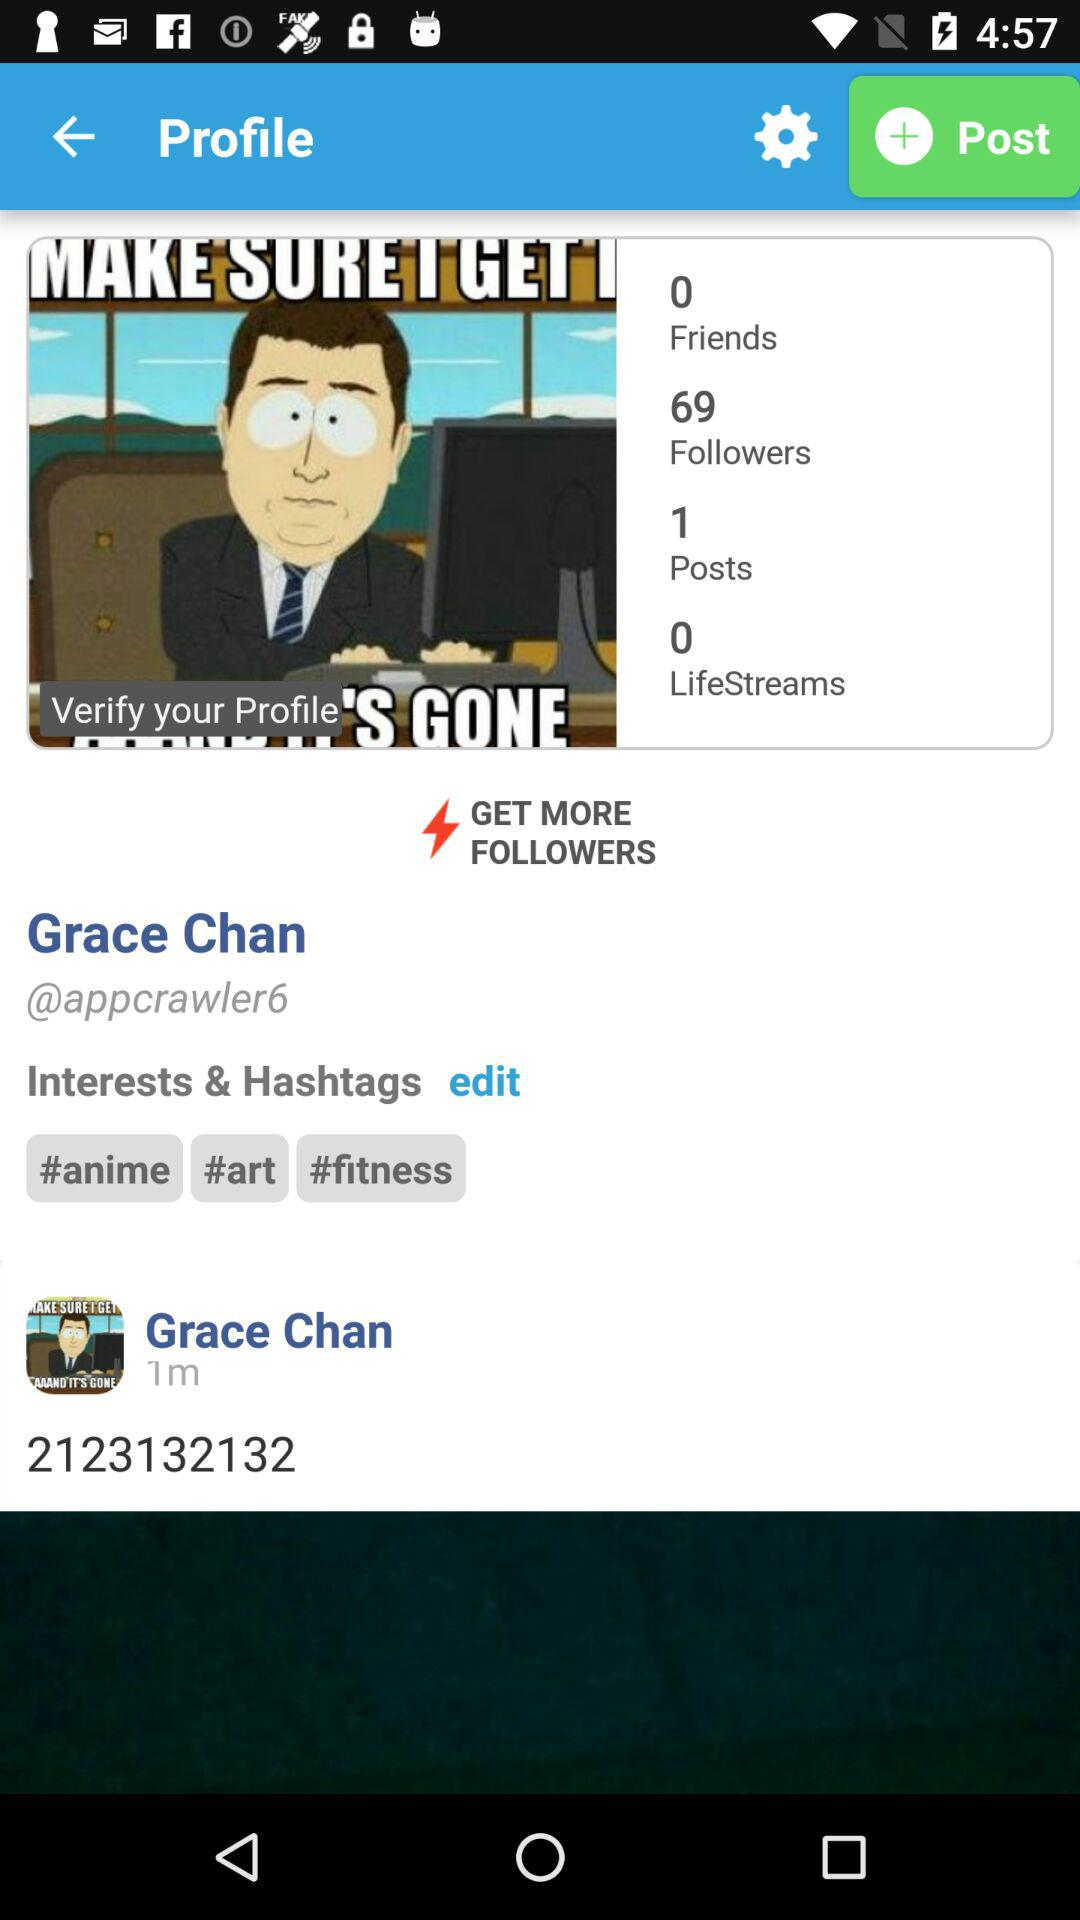What's the name of the user? The name of the user is Grace Chan. 